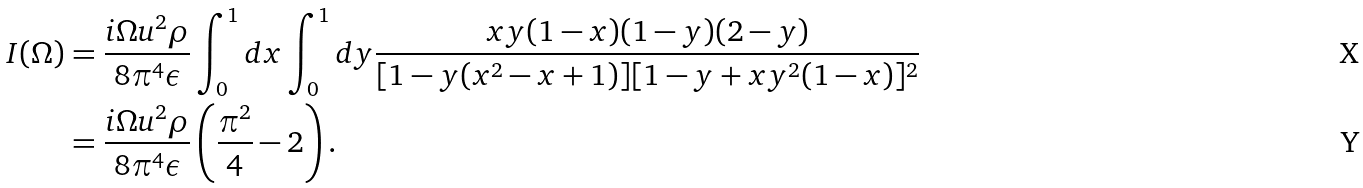Convert formula to latex. <formula><loc_0><loc_0><loc_500><loc_500>I ( \Omega ) & = \frac { i \Omega u ^ { 2 } \rho } { 8 \pi ^ { 4 } \epsilon } \int _ { 0 } ^ { 1 } d x \int _ { 0 } ^ { 1 } d y \frac { x y ( 1 - x ) ( 1 - y ) ( 2 - y ) } { [ 1 - y ( x ^ { 2 } - x + 1 ) ] [ 1 - y + x y ^ { 2 } ( 1 - x ) ] ^ { 2 } } \\ & = \frac { i \Omega u ^ { 2 } \rho } { 8 \pi ^ { 4 } \epsilon } \left ( \frac { \pi ^ { 2 } } { 4 } - 2 \right ) .</formula> 